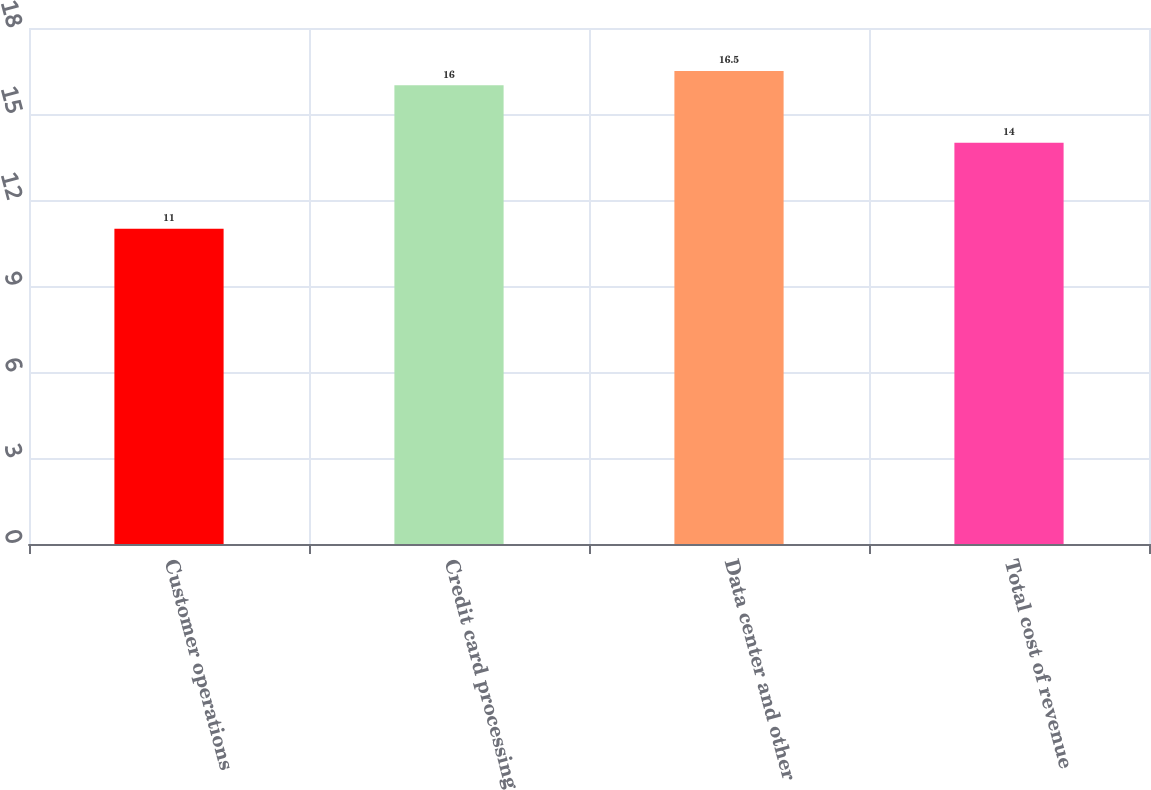Convert chart. <chart><loc_0><loc_0><loc_500><loc_500><bar_chart><fcel>Customer operations<fcel>Credit card processing<fcel>Data center and other<fcel>Total cost of revenue<nl><fcel>11<fcel>16<fcel>16.5<fcel>14<nl></chart> 